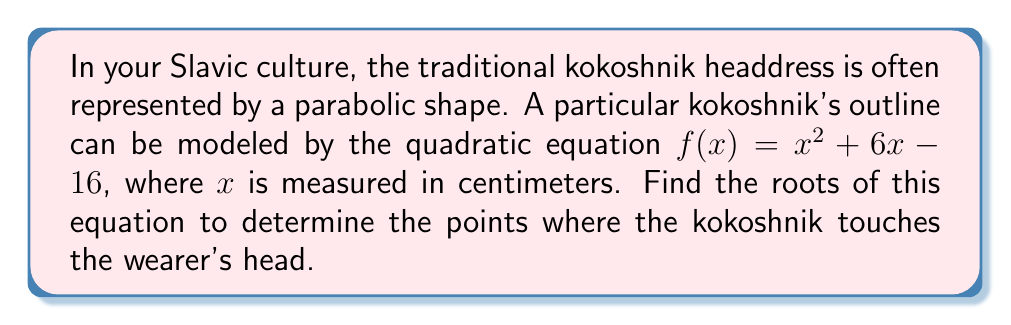Give your solution to this math problem. To find the roots of the quadratic equation $f(x) = x^2 + 6x - 16$, we need to solve $f(x) = 0$. Let's use the quadratic formula:

For a quadratic equation in the form $ax^2 + bx + c = 0$, the roots are given by:

$$ x = \frac{-b \pm \sqrt{b^2 - 4ac}}{2a} $$

In our case:
$a = 1$
$b = 6$
$c = -16$

Substituting these values into the quadratic formula:

$$ x = \frac{-6 \pm \sqrt{6^2 - 4(1)(-16)}}{2(1)} $$

$$ x = \frac{-6 \pm \sqrt{36 + 64}}{2} $$

$$ x = \frac{-6 \pm \sqrt{100}}{2} $$

$$ x = \frac{-6 \pm 10}{2} $$

This gives us two solutions:

$$ x = \frac{-6 + 10}{2} = \frac{4}{2} = 2 $$

$$ x = \frac{-6 - 10}{2} = \frac{-16}{2} = -8 $$

Therefore, the roots of the equation are 2 and -8.
Answer: The roots of the equation $f(x) = x^2 + 6x - 16$ are $x = 2$ and $x = -8$. These represent the points where the kokoshnik touches the wearer's head, at 2 cm and -8 cm on the x-axis. 